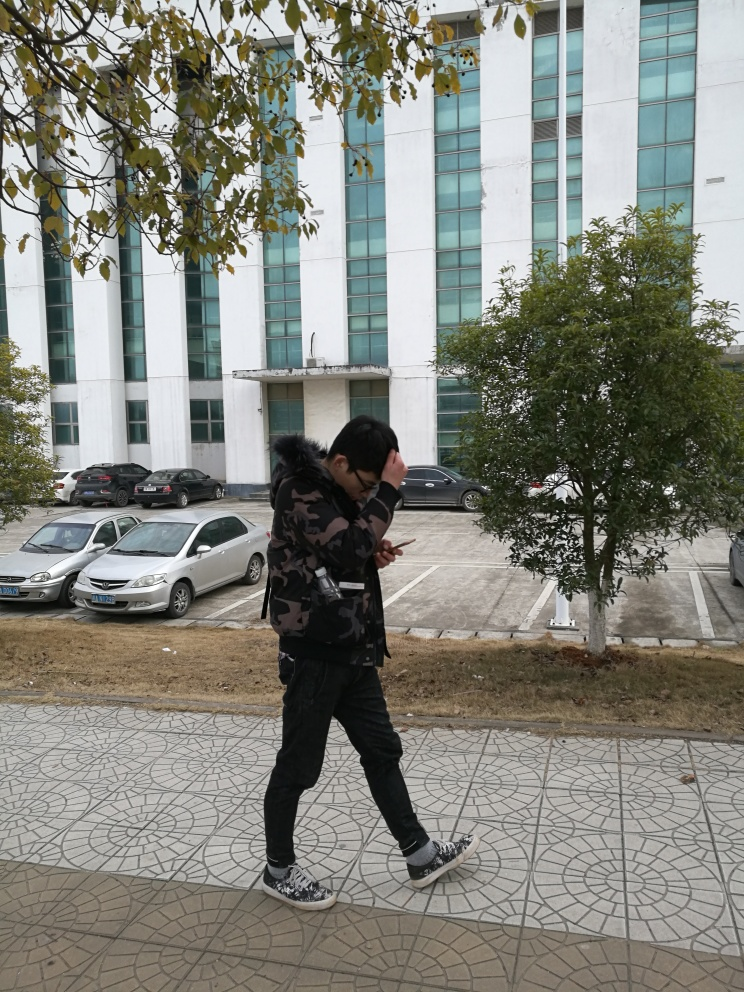What are the weather conditions like in the image? The weather seems to be cool or mild, as indicated by the person wearing a jacket. There's no indication of rain or harsh sunlight, suggesting a possibly overcast or partly cloudy day. 